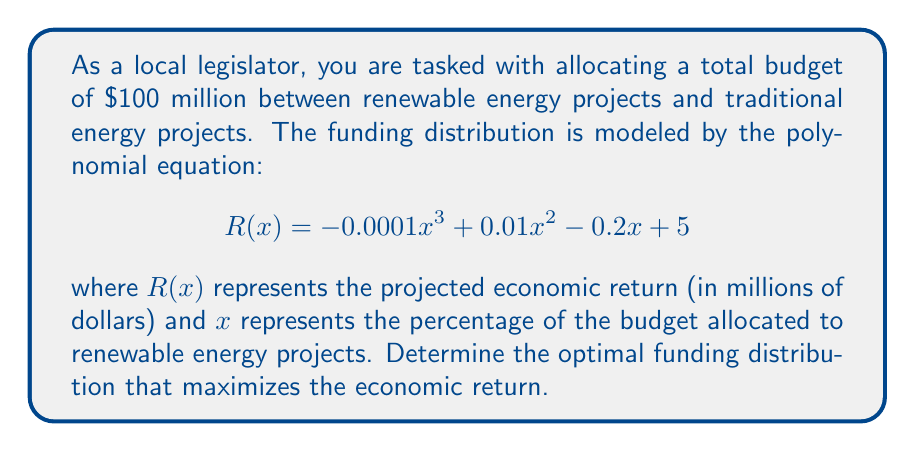Help me with this question. To find the optimal funding distribution, we need to find the maximum value of the function $R(x)$. This occurs where the derivative of $R(x)$ is equal to zero.

1) First, let's find the derivative of $R(x)$:
   $$R'(x) = -0.0003x^2 + 0.02x - 0.2$$

2) Set $R'(x) = 0$ and solve for $x$:
   $$-0.0003x^2 + 0.02x - 0.2 = 0$$

3) This is a quadratic equation. We can solve it using the quadratic formula:
   $$x = \frac{-b \pm \sqrt{b^2 - 4ac}}{2a}$$
   where $a = -0.0003$, $b = 0.02$, and $c = -0.2$

4) Plugging in these values:
   $$x = \frac{-0.02 \pm \sqrt{0.02^2 - 4(-0.0003)(-0.2)}}{2(-0.0003)}$$

5) Simplifying:
   $$x = \frac{-0.02 \pm \sqrt{0.0004 + 0.00024}}{-0.0006}$$
   $$x = \frac{-0.02 \pm \sqrt{0.00064}}{-0.0006}$$
   $$x = \frac{-0.02 \pm 0.025298}{-0.0006}$$

6) This gives us two solutions:
   $$x_1 = \frac{-0.02 + 0.025298}{-0.0006} \approx 8.83$$
   $$x_2 = \frac{-0.02 - 0.025298}{-0.0006} \approx 75.50$$

7) To determine which of these is the maximum (rather than the minimum), we can check the second derivative:
   $$R''(x) = -0.0006x + 0.02$$

   At $x = 8.83$, $R''(8.83) = 0.01470 > 0$, indicating a local minimum.
   At $x = 75.50$, $R''(75.50) = -0.02530 < 0$, indicating a local maximum.

Therefore, the optimal funding distribution is approximately 75.50% for renewable energy projects and 24.50% for traditional energy projects.
Answer: The optimal funding distribution is approximately 75.50% ($75.5 million) for renewable energy projects and 24.50% ($24.5 million) for traditional energy projects. 